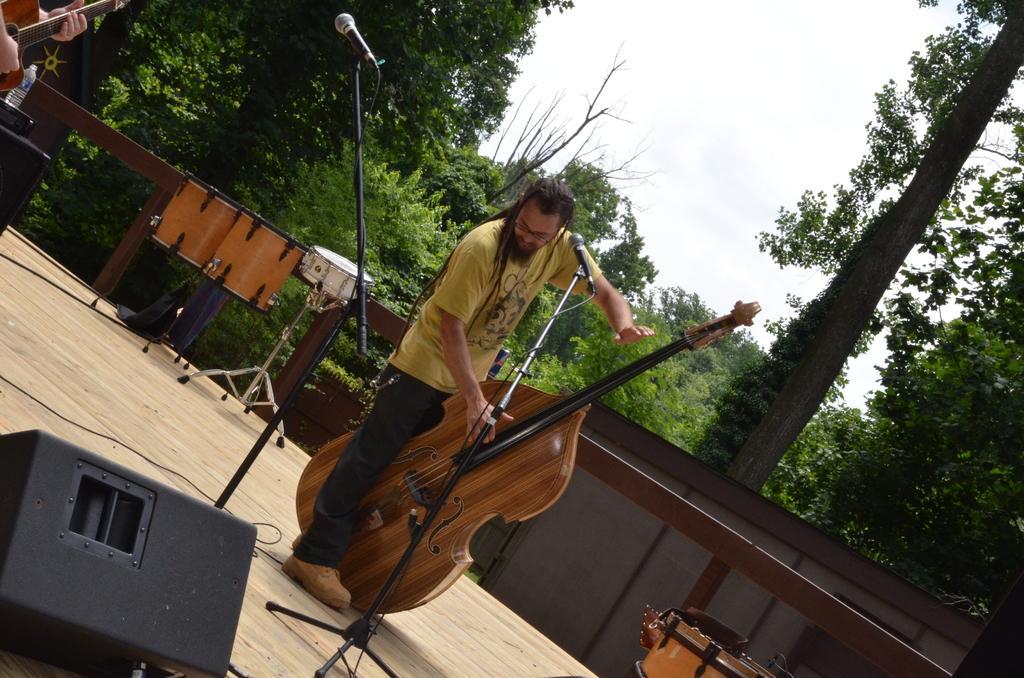Can you describe this image briefly? In this image we can see a two person standing on the stage. In front the person is holding a guitar. There is a mic and stand. At the background there are trees and a sky. 